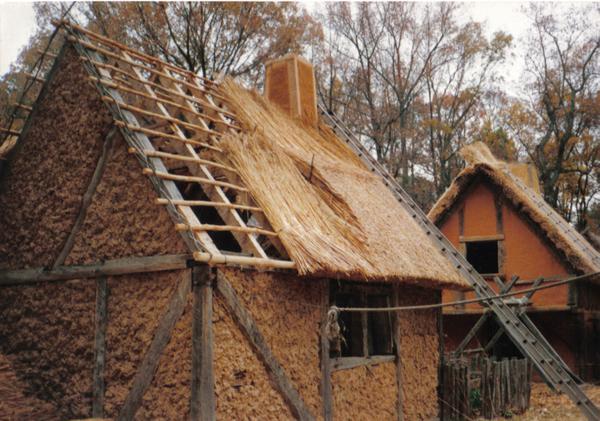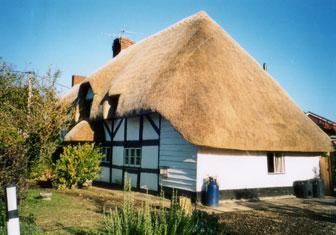The first image is the image on the left, the second image is the image on the right. Evaluate the accuracy of this statement regarding the images: "In at least one image there is a white house with black angle strips on it.". Is it true? Answer yes or no. Yes. 